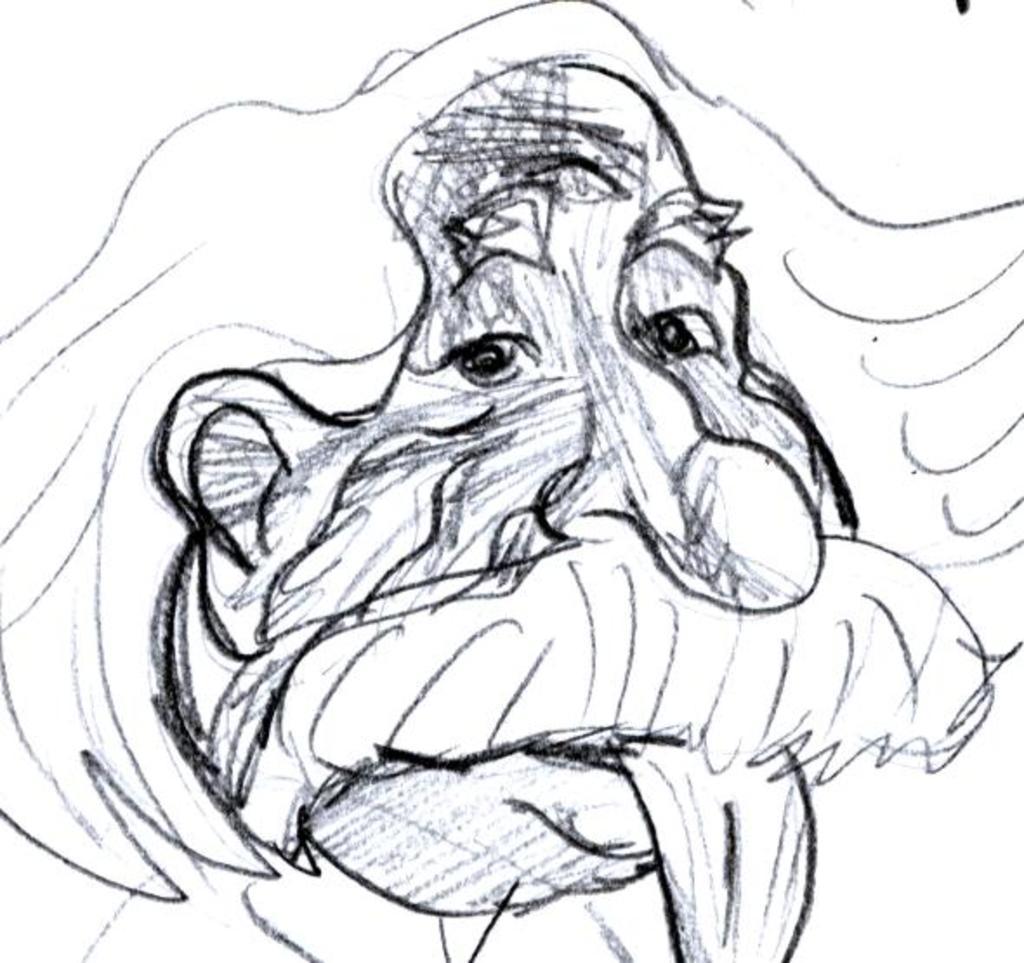What is depicted in the image? There is a drawing of a person's face in the image. What type of furniture is shown in the drawing of the person's face? There is no furniture present in the drawing of the person's face; it is a drawing of a face only. 